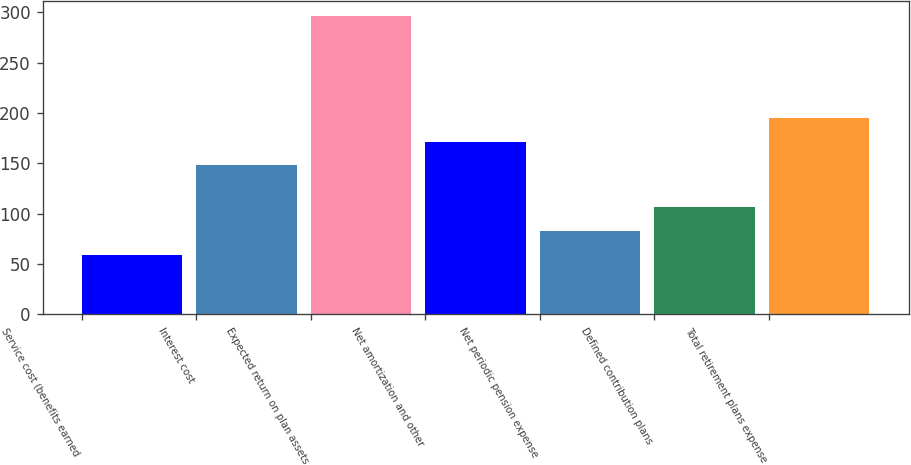Convert chart. <chart><loc_0><loc_0><loc_500><loc_500><bar_chart><fcel>Service cost (benefits earned<fcel>Interest cost<fcel>Expected return on plan assets<fcel>Net amortization and other<fcel>Net periodic pension expense<fcel>Defined contribution plans<fcel>Total retirement plans expense<nl><fcel>59<fcel>148<fcel>296<fcel>171.7<fcel>82.7<fcel>106.4<fcel>195.4<nl></chart> 